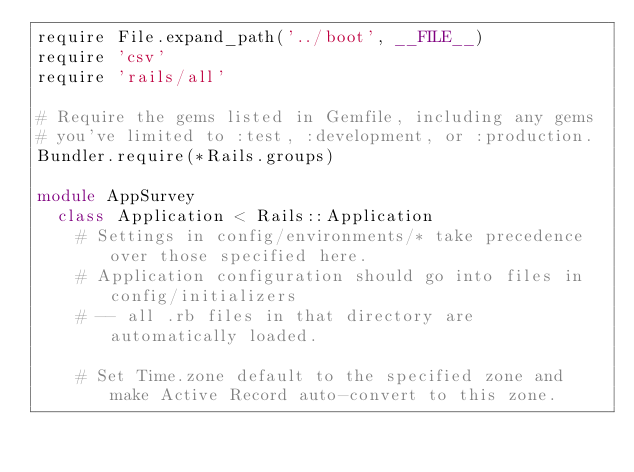Convert code to text. <code><loc_0><loc_0><loc_500><loc_500><_Ruby_>require File.expand_path('../boot', __FILE__)
require 'csv'
require 'rails/all'

# Require the gems listed in Gemfile, including any gems
# you've limited to :test, :development, or :production.
Bundler.require(*Rails.groups)

module AppSurvey
  class Application < Rails::Application
    # Settings in config/environments/* take precedence over those specified here.
    # Application configuration should go into files in config/initializers
    # -- all .rb files in that directory are automatically loaded.

    # Set Time.zone default to the specified zone and make Active Record auto-convert to this zone.</code> 